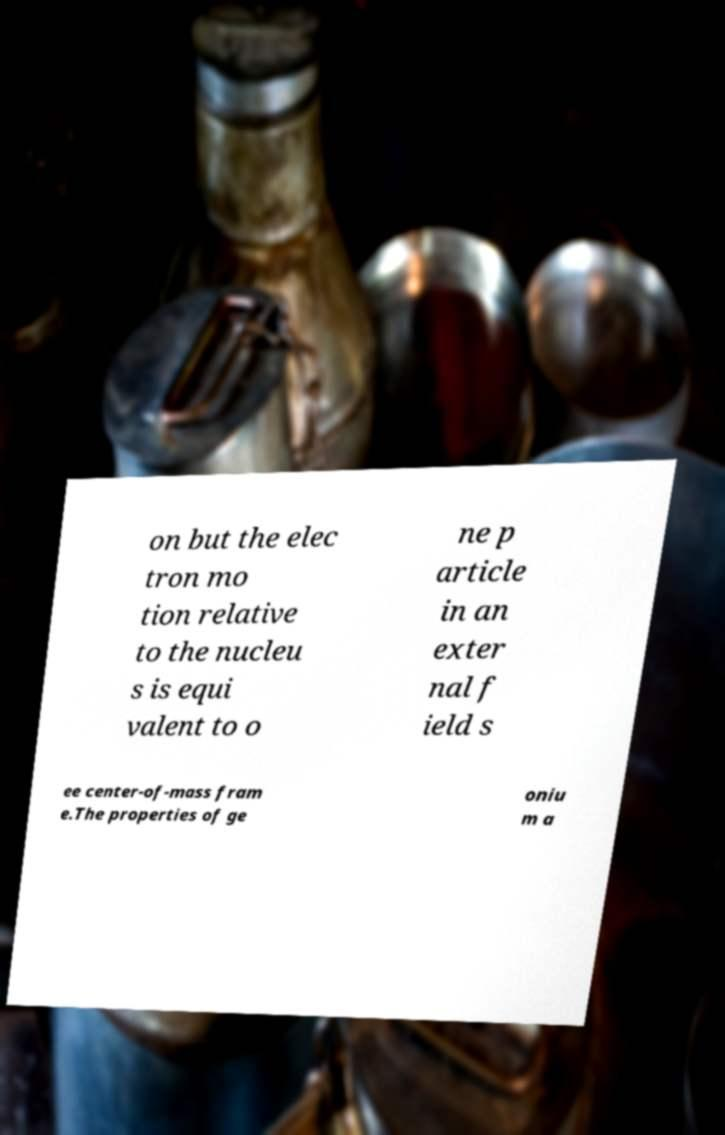Could you extract and type out the text from this image? on but the elec tron mo tion relative to the nucleu s is equi valent to o ne p article in an exter nal f ield s ee center-of-mass fram e.The properties of ge oniu m a 